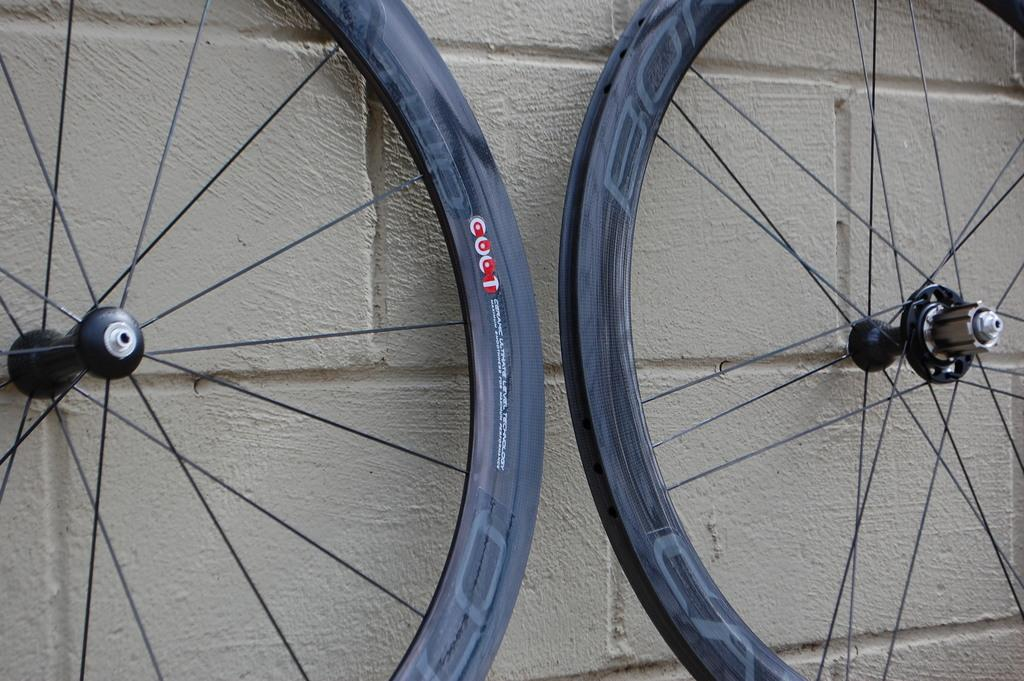What objects are present in the image that have wheels? There are two wheels in the image. What color is the background of the image? The background of the image is cream-colored. Can you see a river flowing in the background of the image? There is no river visible in the image; the background is cream-colored. Is there an amusement park present in the image? There is no amusement park visible in the image; only the two wheels and the cream-colored background are present. 